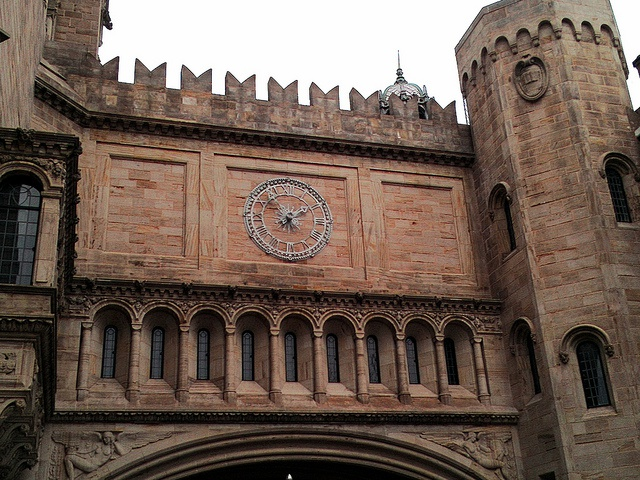Describe the objects in this image and their specific colors. I can see a clock in gray and darkgray tones in this image. 